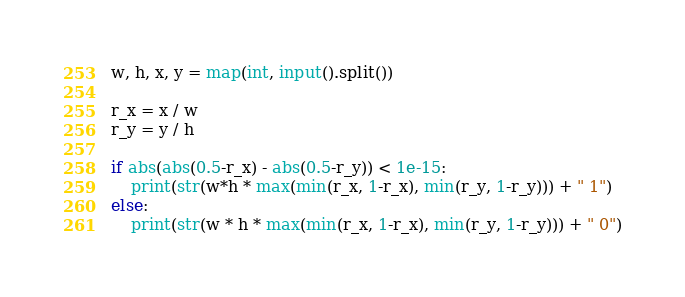Convert code to text. <code><loc_0><loc_0><loc_500><loc_500><_Python_>w, h, x, y = map(int, input().split())

r_x = x / w
r_y = y / h

if abs(abs(0.5-r_x) - abs(0.5-r_y)) < 1e-15:
    print(str(w*h * max(min(r_x, 1-r_x), min(r_y, 1-r_y))) + " 1")
else:
    print(str(w * h * max(min(r_x, 1-r_x), min(r_y, 1-r_y))) + " 0")</code> 